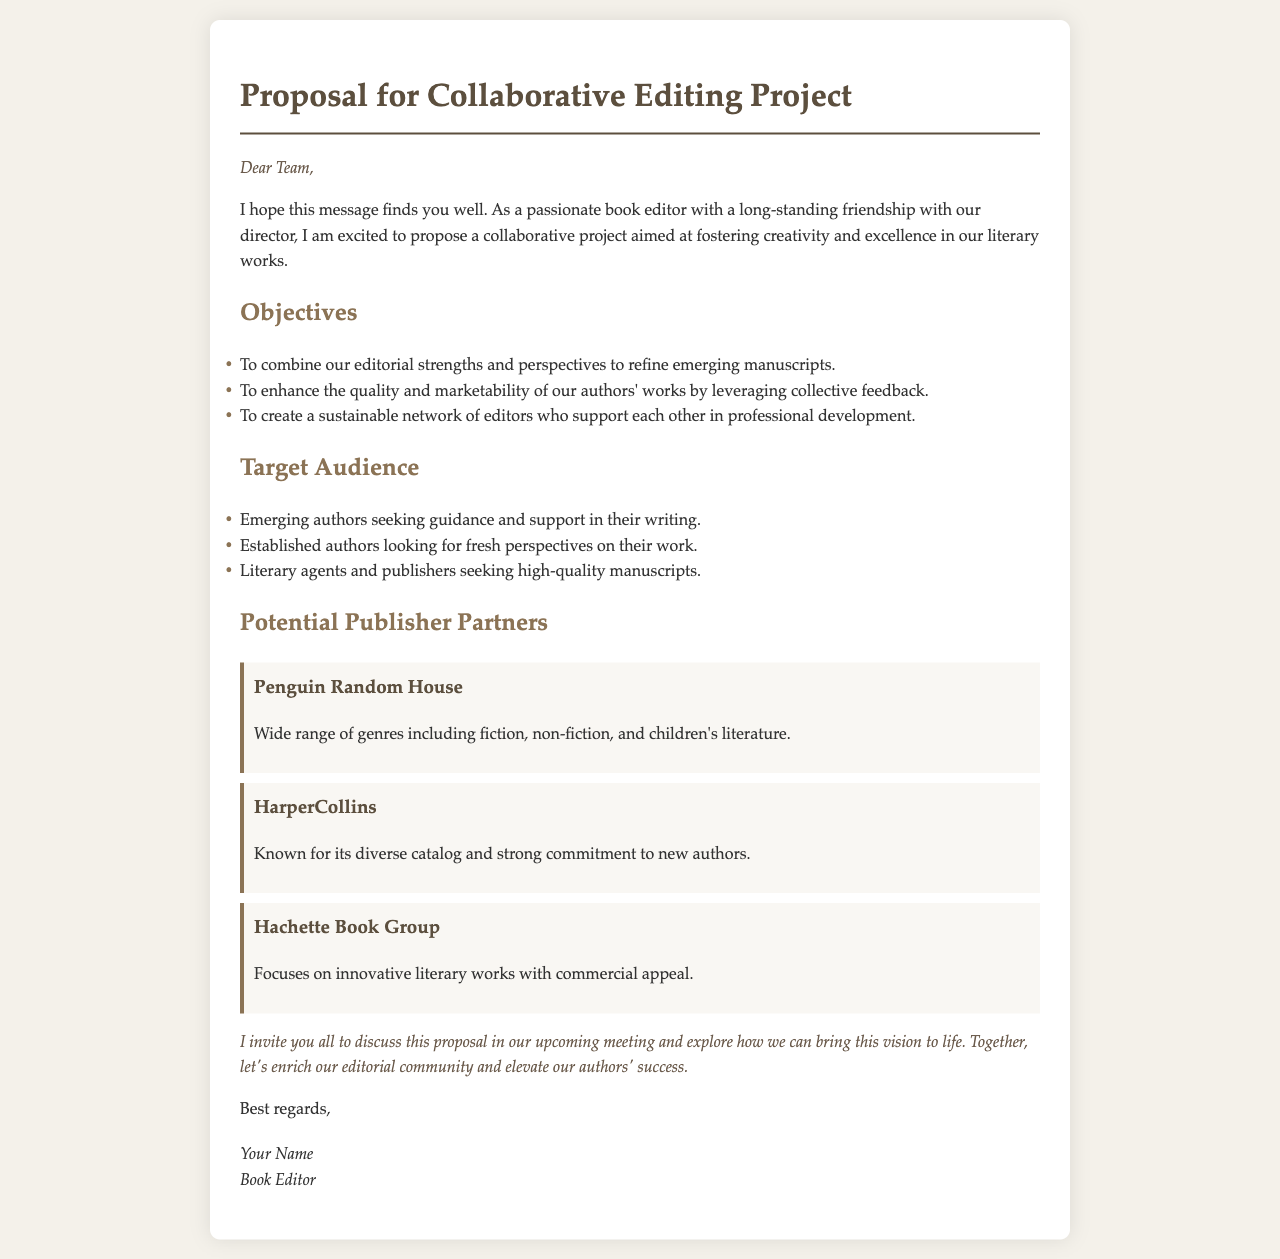what is the title of the proposal? The title of the proposal is given in the document header, which states the purpose of the email.
Answer: Proposal for Collaborative Editing Project who is the intended audience for this proposal? The intended audience is mentioned in the "Target Audience" section, describing those who would benefit from the project.
Answer: Emerging authors, Established authors, Literary agents, and publishers what is one of the objectives of the project? The objectives are clearly listed in the section titled "Objectives," where specific goals for the project are provided.
Answer: To enhance the quality and marketability of our authors' works which publisher is mentioned first in the potential publisher partners? The document lists potential publisher partners, and the order in which they are mentioned is relevant.
Answer: Penguin Random House how many potential publisher partners are listed? The number of publisher partners is determined by counting the items in the "Potential Publisher Partners" section.
Answer: Three 